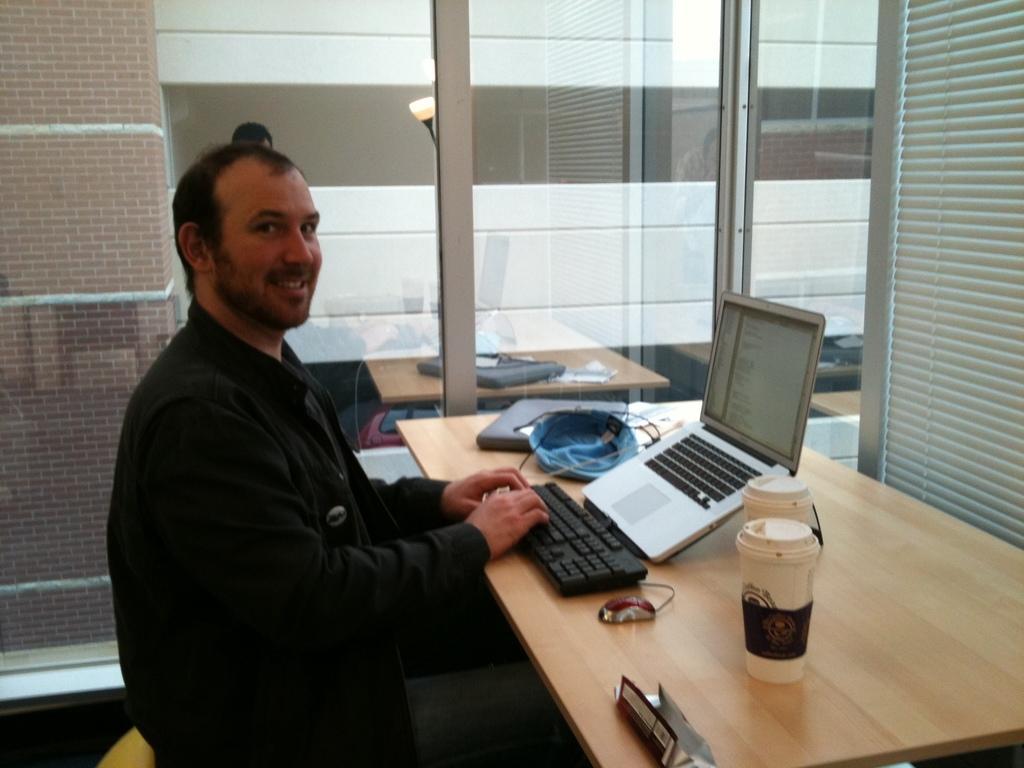Please provide a concise description of this image. In the center we can see man sitting on the chair. In front of him we can see the table,on the table we can see tab,mouse,cap etc. Coming to the background we can see the wall and glass. 